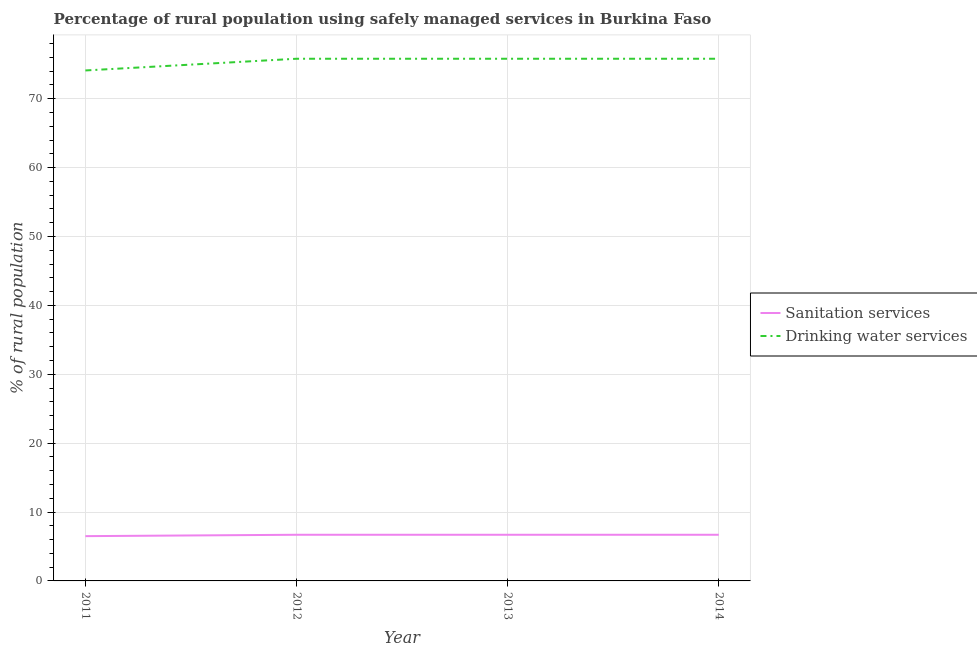How many different coloured lines are there?
Your response must be concise. 2. Does the line corresponding to percentage of rural population who used sanitation services intersect with the line corresponding to percentage of rural population who used drinking water services?
Your response must be concise. No. Is the number of lines equal to the number of legend labels?
Keep it short and to the point. Yes. Across all years, what is the maximum percentage of rural population who used sanitation services?
Ensure brevity in your answer.  6.7. Across all years, what is the minimum percentage of rural population who used sanitation services?
Make the answer very short. 6.5. In which year was the percentage of rural population who used drinking water services minimum?
Provide a succinct answer. 2011. What is the total percentage of rural population who used sanitation services in the graph?
Keep it short and to the point. 26.6. What is the difference between the percentage of rural population who used sanitation services in 2011 and that in 2013?
Provide a short and direct response. -0.2. What is the difference between the percentage of rural population who used sanitation services in 2013 and the percentage of rural population who used drinking water services in 2011?
Provide a succinct answer. -67.4. What is the average percentage of rural population who used sanitation services per year?
Make the answer very short. 6.65. In the year 2014, what is the difference between the percentage of rural population who used drinking water services and percentage of rural population who used sanitation services?
Your answer should be very brief. 69.1. In how many years, is the percentage of rural population who used drinking water services greater than 42 %?
Provide a short and direct response. 4. What is the ratio of the percentage of rural population who used drinking water services in 2011 to that in 2014?
Your answer should be very brief. 0.98. Is the percentage of rural population who used drinking water services in 2013 less than that in 2014?
Your answer should be compact. No. Is the difference between the percentage of rural population who used sanitation services in 2011 and 2014 greater than the difference between the percentage of rural population who used drinking water services in 2011 and 2014?
Give a very brief answer. Yes. What is the difference between the highest and the second highest percentage of rural population who used sanitation services?
Your answer should be very brief. 0. What is the difference between the highest and the lowest percentage of rural population who used drinking water services?
Your answer should be compact. 1.7. In how many years, is the percentage of rural population who used sanitation services greater than the average percentage of rural population who used sanitation services taken over all years?
Your answer should be very brief. 3. Is the sum of the percentage of rural population who used drinking water services in 2011 and 2014 greater than the maximum percentage of rural population who used sanitation services across all years?
Your answer should be very brief. Yes. Does the percentage of rural population who used drinking water services monotonically increase over the years?
Your response must be concise. No. Is the percentage of rural population who used sanitation services strictly greater than the percentage of rural population who used drinking water services over the years?
Provide a succinct answer. No. Is the percentage of rural population who used sanitation services strictly less than the percentage of rural population who used drinking water services over the years?
Provide a succinct answer. Yes. How many lines are there?
Your response must be concise. 2. How many years are there in the graph?
Your answer should be very brief. 4. Are the values on the major ticks of Y-axis written in scientific E-notation?
Provide a short and direct response. No. Does the graph contain any zero values?
Provide a short and direct response. No. Where does the legend appear in the graph?
Provide a short and direct response. Center right. How many legend labels are there?
Offer a very short reply. 2. What is the title of the graph?
Ensure brevity in your answer.  Percentage of rural population using safely managed services in Burkina Faso. What is the label or title of the X-axis?
Ensure brevity in your answer.  Year. What is the label or title of the Y-axis?
Give a very brief answer. % of rural population. What is the % of rural population in Sanitation services in 2011?
Provide a short and direct response. 6.5. What is the % of rural population of Drinking water services in 2011?
Give a very brief answer. 74.1. What is the % of rural population in Sanitation services in 2012?
Make the answer very short. 6.7. What is the % of rural population of Drinking water services in 2012?
Make the answer very short. 75.8. What is the % of rural population in Sanitation services in 2013?
Your answer should be very brief. 6.7. What is the % of rural population in Drinking water services in 2013?
Offer a very short reply. 75.8. What is the % of rural population of Drinking water services in 2014?
Provide a short and direct response. 75.8. Across all years, what is the maximum % of rural population of Sanitation services?
Make the answer very short. 6.7. Across all years, what is the maximum % of rural population in Drinking water services?
Keep it short and to the point. 75.8. Across all years, what is the minimum % of rural population in Sanitation services?
Offer a very short reply. 6.5. Across all years, what is the minimum % of rural population of Drinking water services?
Your answer should be very brief. 74.1. What is the total % of rural population in Sanitation services in the graph?
Your answer should be very brief. 26.6. What is the total % of rural population in Drinking water services in the graph?
Your answer should be compact. 301.5. What is the difference between the % of rural population in Drinking water services in 2011 and that in 2012?
Give a very brief answer. -1.7. What is the difference between the % of rural population of Sanitation services in 2011 and the % of rural population of Drinking water services in 2012?
Your response must be concise. -69.3. What is the difference between the % of rural population of Sanitation services in 2011 and the % of rural population of Drinking water services in 2013?
Provide a short and direct response. -69.3. What is the difference between the % of rural population of Sanitation services in 2011 and the % of rural population of Drinking water services in 2014?
Make the answer very short. -69.3. What is the difference between the % of rural population in Sanitation services in 2012 and the % of rural population in Drinking water services in 2013?
Offer a very short reply. -69.1. What is the difference between the % of rural population in Sanitation services in 2012 and the % of rural population in Drinking water services in 2014?
Offer a very short reply. -69.1. What is the difference between the % of rural population of Sanitation services in 2013 and the % of rural population of Drinking water services in 2014?
Make the answer very short. -69.1. What is the average % of rural population of Sanitation services per year?
Your answer should be very brief. 6.65. What is the average % of rural population in Drinking water services per year?
Ensure brevity in your answer.  75.38. In the year 2011, what is the difference between the % of rural population in Sanitation services and % of rural population in Drinking water services?
Ensure brevity in your answer.  -67.6. In the year 2012, what is the difference between the % of rural population of Sanitation services and % of rural population of Drinking water services?
Give a very brief answer. -69.1. In the year 2013, what is the difference between the % of rural population of Sanitation services and % of rural population of Drinking water services?
Provide a succinct answer. -69.1. In the year 2014, what is the difference between the % of rural population in Sanitation services and % of rural population in Drinking water services?
Your response must be concise. -69.1. What is the ratio of the % of rural population in Sanitation services in 2011 to that in 2012?
Provide a short and direct response. 0.97. What is the ratio of the % of rural population in Drinking water services in 2011 to that in 2012?
Your answer should be compact. 0.98. What is the ratio of the % of rural population in Sanitation services in 2011 to that in 2013?
Provide a short and direct response. 0.97. What is the ratio of the % of rural population of Drinking water services in 2011 to that in 2013?
Ensure brevity in your answer.  0.98. What is the ratio of the % of rural population in Sanitation services in 2011 to that in 2014?
Make the answer very short. 0.97. What is the ratio of the % of rural population in Drinking water services in 2011 to that in 2014?
Offer a very short reply. 0.98. What is the ratio of the % of rural population in Sanitation services in 2012 to that in 2013?
Make the answer very short. 1. What is the ratio of the % of rural population in Sanitation services in 2012 to that in 2014?
Ensure brevity in your answer.  1. What is the ratio of the % of rural population of Drinking water services in 2012 to that in 2014?
Offer a terse response. 1. What is the ratio of the % of rural population of Sanitation services in 2013 to that in 2014?
Your answer should be compact. 1. What is the ratio of the % of rural population of Drinking water services in 2013 to that in 2014?
Make the answer very short. 1. 